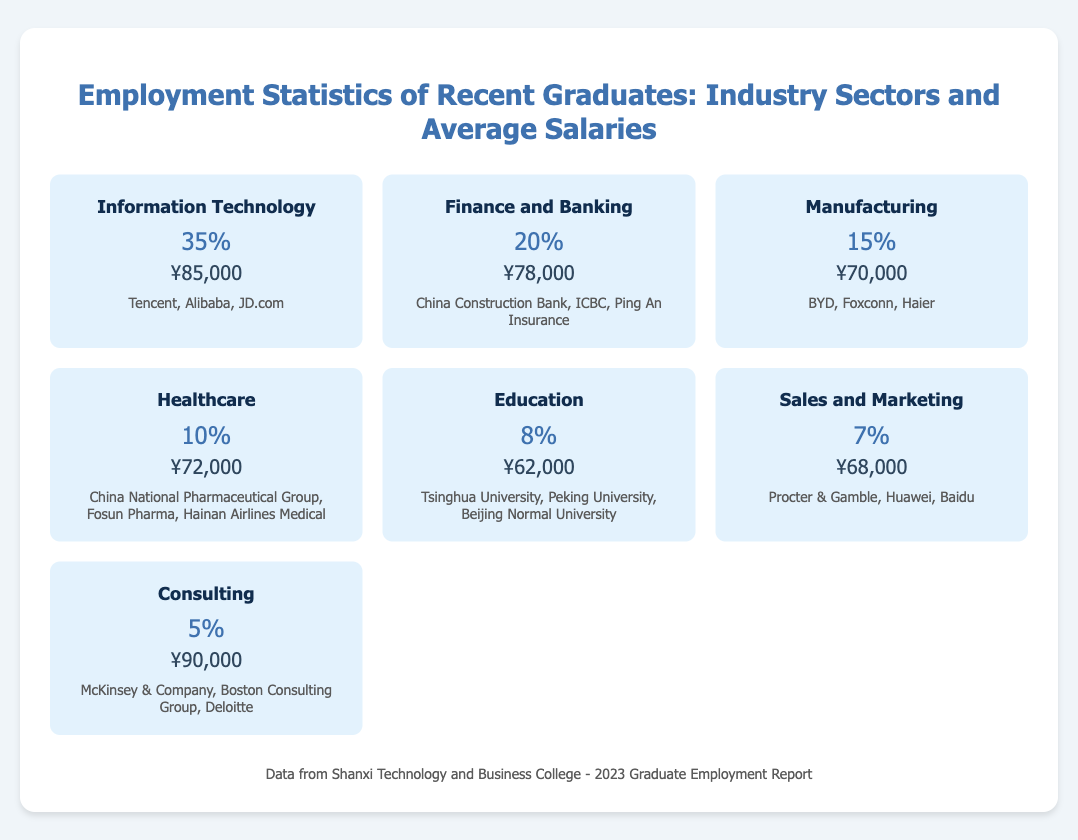What percentage of graduates are employed in Information Technology? The document states that 35% of graduates are employed in the Information Technology sector.
Answer: 35% What is the average salary for graduates in Finance and Banking? The average salary listed for the Finance and Banking sector is ¥78,000.
Answer: ¥78,000 Which industry has the least percentage of employed graduates? The industry with the least percentage of employed graduates is Consulting, at 5%.
Answer: Consulting What employers are listed for the Manufacturing sector? The document mentions BYD, Foxconn, and Haier as employers in the Manufacturing sector.
Answer: BYD, Foxconn, Haier Which sector has the highest average salary? The Consulting sector has the highest average salary at ¥90,000.
Answer: ¥90,000 How many sectors are represented in the employment statistics? There are seven sectors represented in the employment statistics.
Answer: Seven What is the total percentage of graduates employed in Healthcare and Education combined? The combined percentage for both Healthcare (10%) and Education (8%) is 18%.
Answer: 18% 